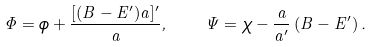<formula> <loc_0><loc_0><loc_500><loc_500>\Phi = \phi + \frac { [ ( B - E ^ { \prime } ) a ] ^ { \prime } } { a } , \quad \Psi = \chi - \frac { a } { a ^ { \prime } } \left ( B - E ^ { \prime } \right ) .</formula> 